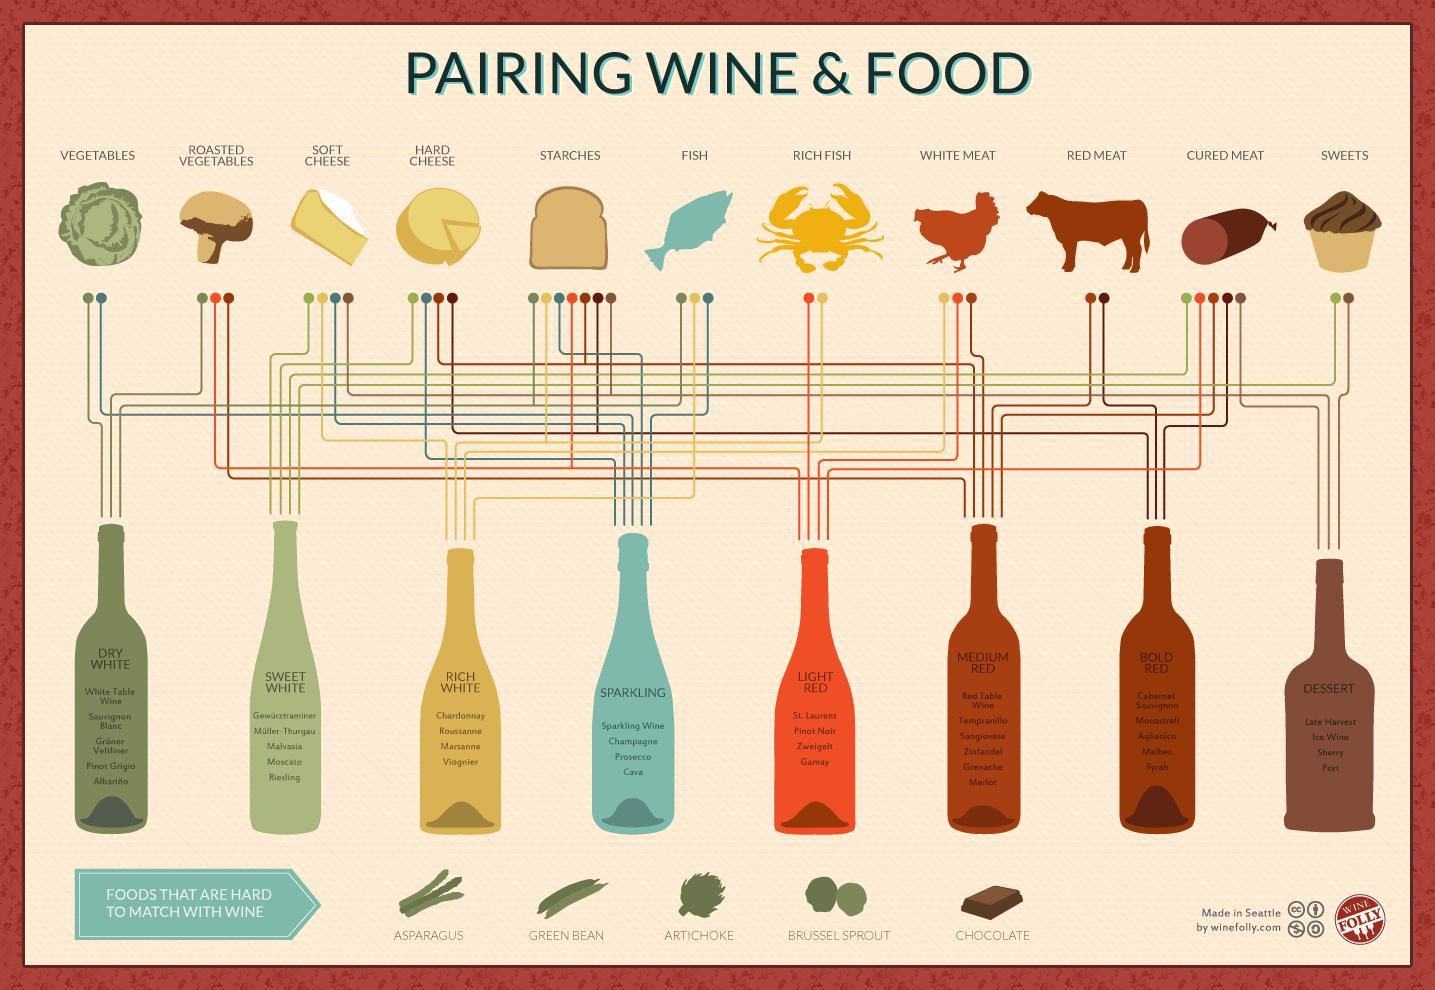Under what type of wine does Pinot Noir fall?
Answer the question with a short phrase. LIGHT RED Which type of sweet is tough to be paired with wine? CHOCOLATE 